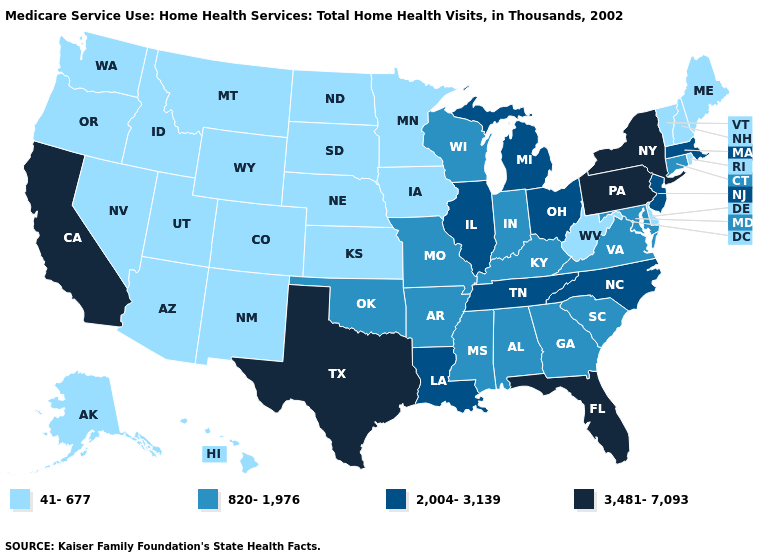Name the states that have a value in the range 2,004-3,139?
Give a very brief answer. Illinois, Louisiana, Massachusetts, Michigan, New Jersey, North Carolina, Ohio, Tennessee. Does North Dakota have the highest value in the USA?
Short answer required. No. What is the highest value in states that border Michigan?
Answer briefly. 2,004-3,139. Does South Carolina have a higher value than Washington?
Answer briefly. Yes. Does the map have missing data?
Answer briefly. No. Which states have the lowest value in the South?
Give a very brief answer. Delaware, West Virginia. Among the states that border Massachusetts , which have the highest value?
Short answer required. New York. Which states have the lowest value in the USA?
Answer briefly. Alaska, Arizona, Colorado, Delaware, Hawaii, Idaho, Iowa, Kansas, Maine, Minnesota, Montana, Nebraska, Nevada, New Hampshire, New Mexico, North Dakota, Oregon, Rhode Island, South Dakota, Utah, Vermont, Washington, West Virginia, Wyoming. What is the value of Mississippi?
Answer briefly. 820-1,976. Does Oregon have a lower value than Wisconsin?
Quick response, please. Yes. What is the value of Mississippi?
Give a very brief answer. 820-1,976. Name the states that have a value in the range 41-677?
Concise answer only. Alaska, Arizona, Colorado, Delaware, Hawaii, Idaho, Iowa, Kansas, Maine, Minnesota, Montana, Nebraska, Nevada, New Hampshire, New Mexico, North Dakota, Oregon, Rhode Island, South Dakota, Utah, Vermont, Washington, West Virginia, Wyoming. Does Washington have the lowest value in the USA?
Write a very short answer. Yes. 